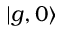Convert formula to latex. <formula><loc_0><loc_0><loc_500><loc_500>| g , 0 \rangle</formula> 